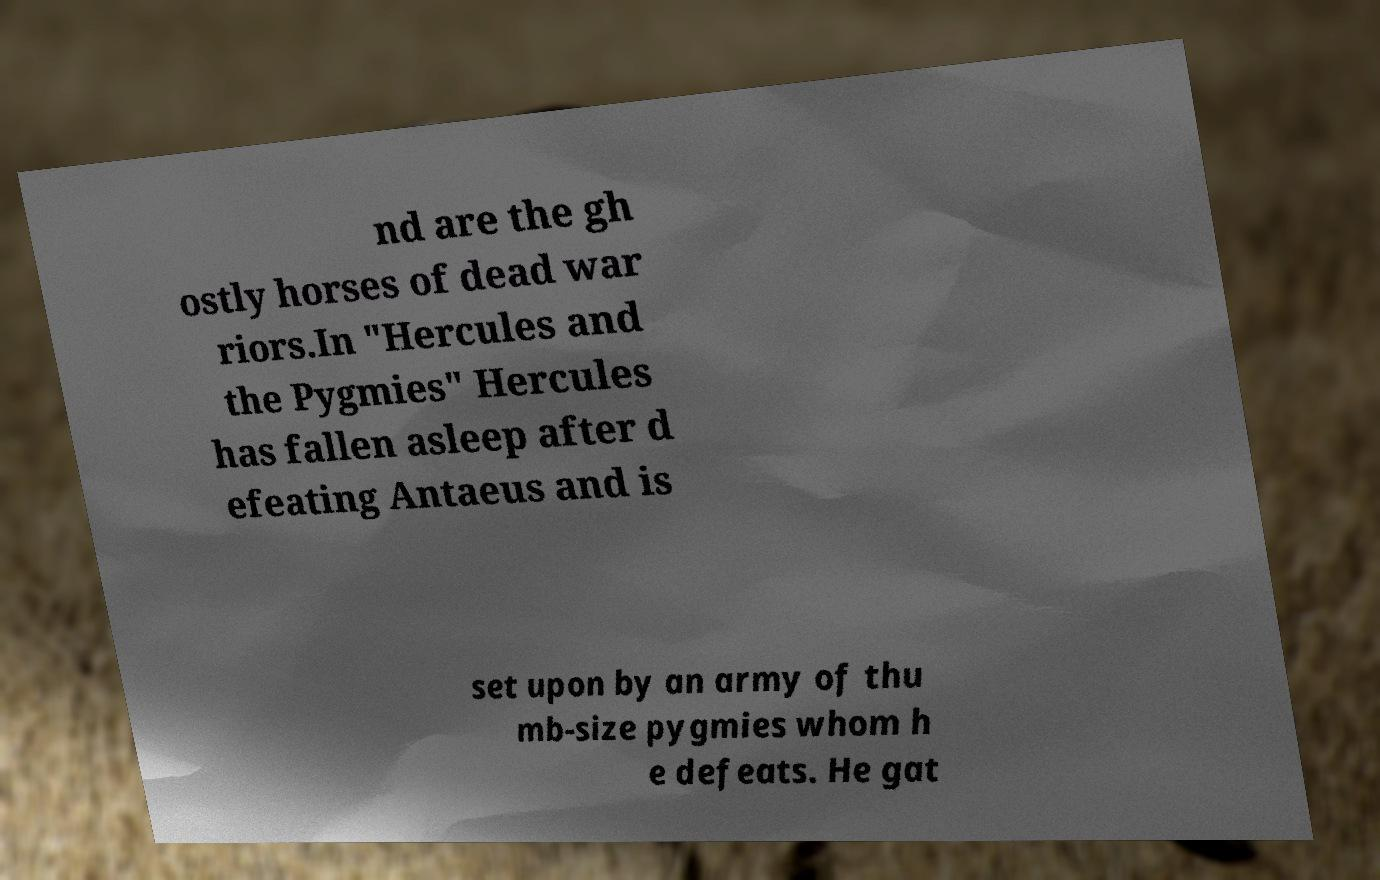Please read and relay the text visible in this image. What does it say? nd are the gh ostly horses of dead war riors.In "Hercules and the Pygmies" Hercules has fallen asleep after d efeating Antaeus and is set upon by an army of thu mb-size pygmies whom h e defeats. He gat 